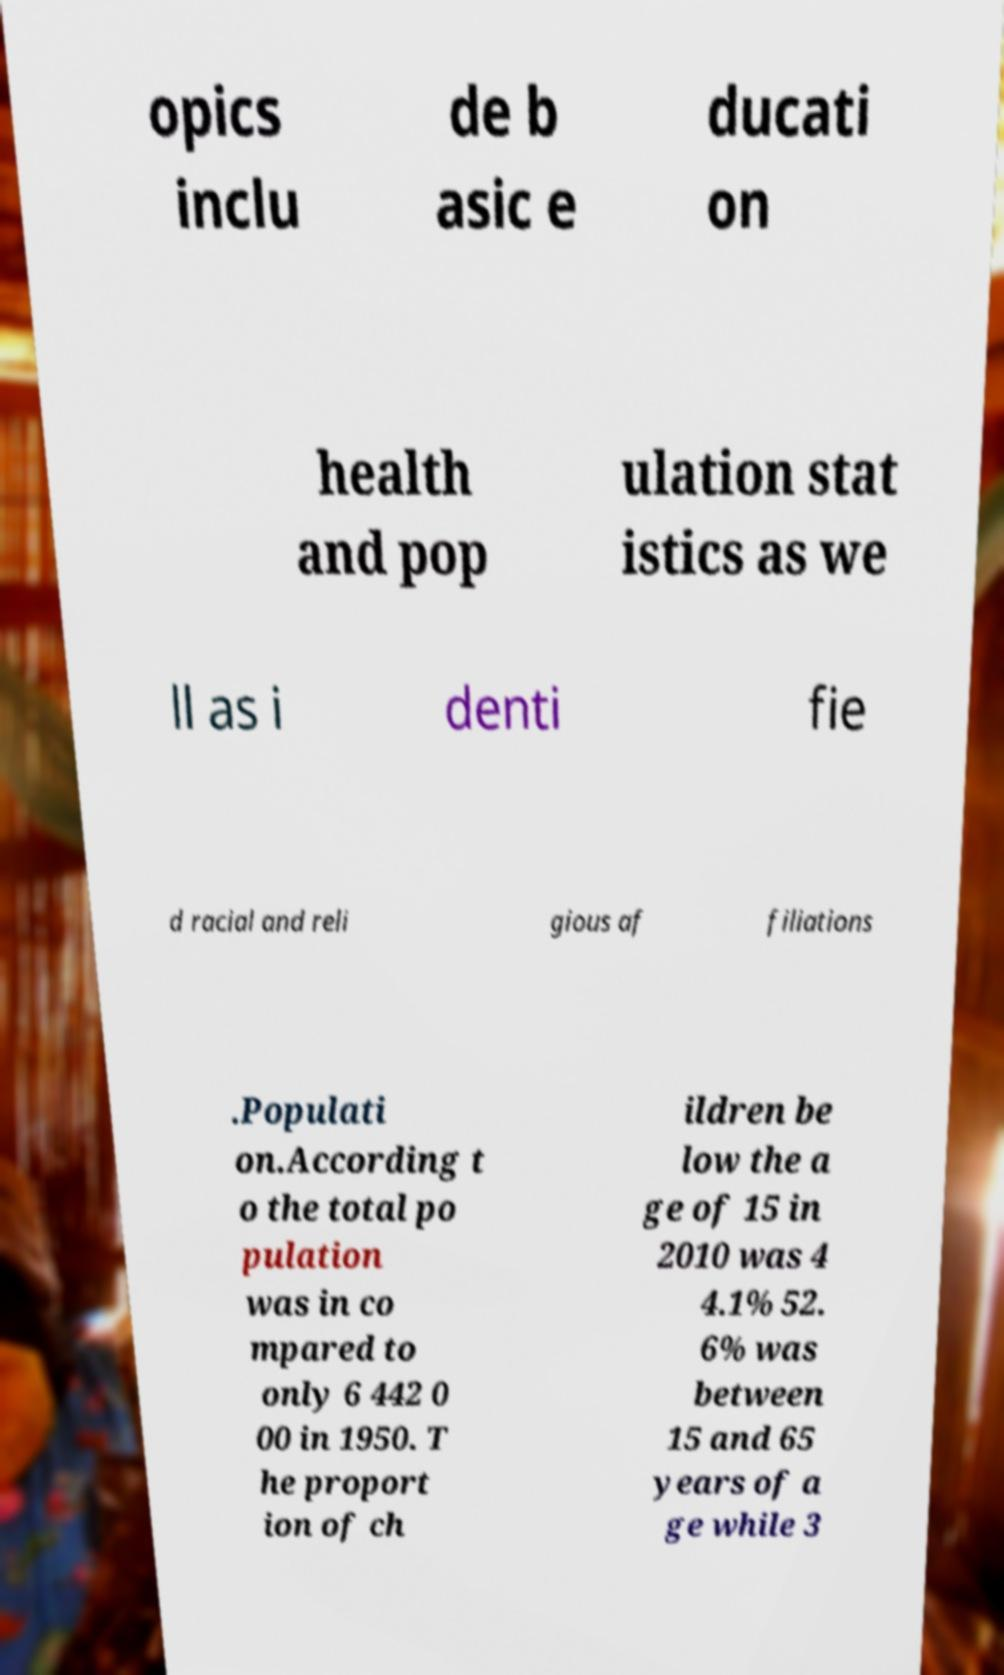Please read and relay the text visible in this image. What does it say? opics inclu de b asic e ducati on health and pop ulation stat istics as we ll as i denti fie d racial and reli gious af filiations .Populati on.According t o the total po pulation was in co mpared to only 6 442 0 00 in 1950. T he proport ion of ch ildren be low the a ge of 15 in 2010 was 4 4.1% 52. 6% was between 15 and 65 years of a ge while 3 